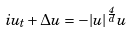<formula> <loc_0><loc_0><loc_500><loc_500>i u _ { t } + \Delta u = - | u | ^ { \frac { 4 } { d } } u</formula> 